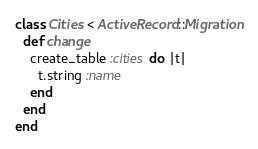<code> <loc_0><loc_0><loc_500><loc_500><_Ruby_>class Cities < ActiveRecord::Migration
  def change
    create_table :cities do |t|
      t.string :name
    end
  end
end</code> 